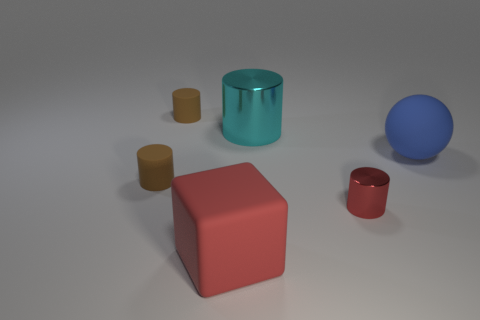Subtract all big cylinders. How many cylinders are left? 3 Add 3 big red blocks. How many objects exist? 9 Subtract all cyan cylinders. How many cylinders are left? 3 Subtract 1 balls. How many balls are left? 0 Subtract all balls. How many objects are left? 5 Subtract all blue rubber objects. Subtract all large green spheres. How many objects are left? 5 Add 1 big red rubber blocks. How many big red rubber blocks are left? 2 Add 6 small cylinders. How many small cylinders exist? 9 Subtract 0 yellow blocks. How many objects are left? 6 Subtract all gray cubes. Subtract all brown cylinders. How many cubes are left? 1 